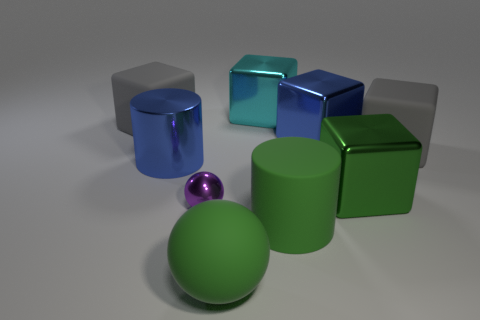There is a big green thing that is left of the large cyan shiny object; does it have the same shape as the large gray thing that is to the left of the green cube?
Your response must be concise. No. What number of matte objects are either green cubes or blue cubes?
Offer a very short reply. 0. There is a big thing that is the same color as the metallic cylinder; what material is it?
Provide a succinct answer. Metal. Are there any other things that have the same shape as the big green shiny thing?
Ensure brevity in your answer.  Yes. What is the material of the blue thing that is right of the shiny cylinder?
Your answer should be very brief. Metal. Are the green thing behind the small purple sphere and the cyan cube made of the same material?
Keep it short and to the point. Yes. What number of objects are either large green blocks or large gray cubes left of the small object?
Make the answer very short. 2. There is another matte thing that is the same shape as the small thing; what size is it?
Your response must be concise. Large. Is there anything else that is the same size as the green rubber sphere?
Provide a short and direct response. Yes. Are there any small purple things right of the large blue shiny cylinder?
Provide a succinct answer. Yes. 